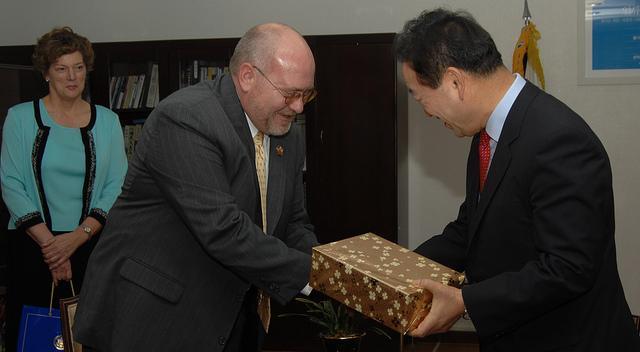How many teddy bears are in the image?
Give a very brief answer. 0. How many people have beards?
Give a very brief answer. 1. How many people are there?
Give a very brief answer. 3. 